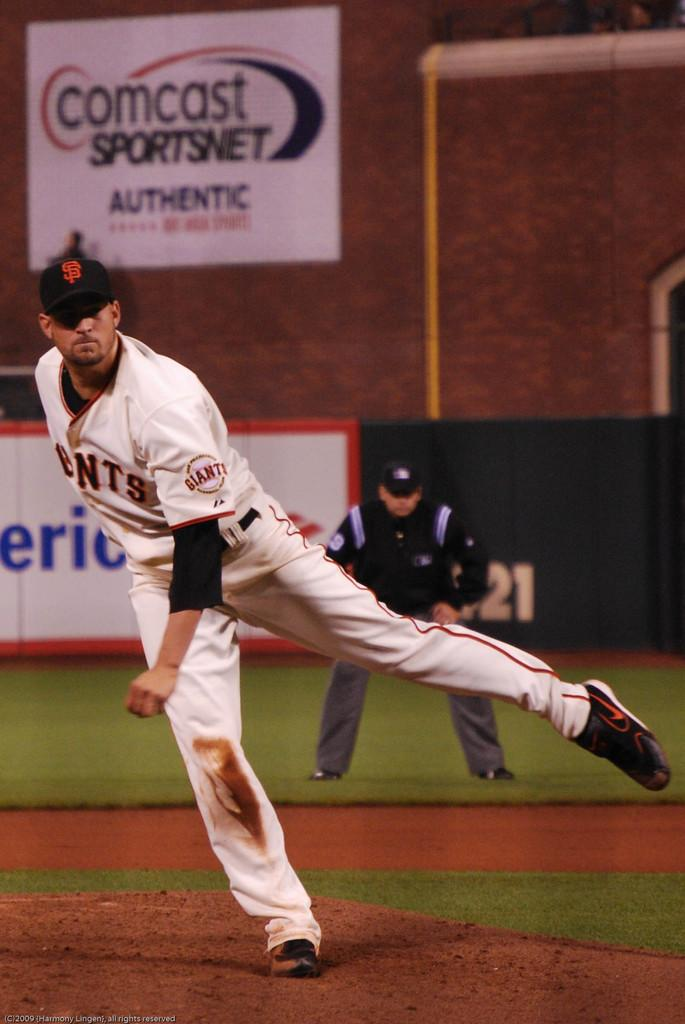<image>
Summarize the visual content of the image. Baseball pitcher playing for team Giants throws the ball sponsored by Comcast. 